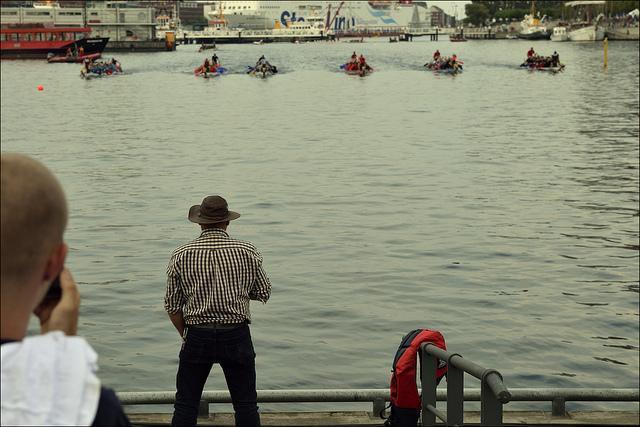How many people can you see?
Give a very brief answer. 2. 